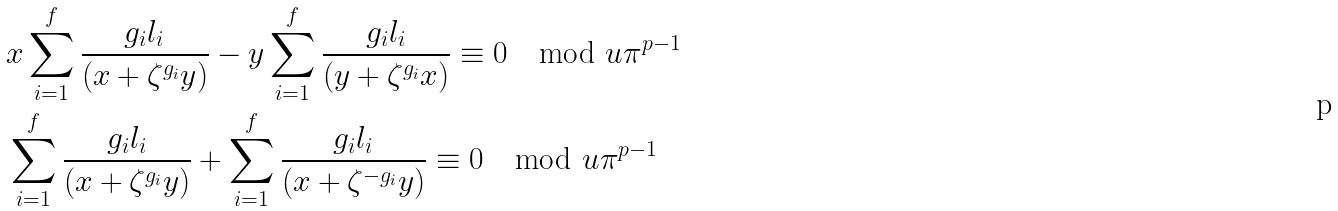<formula> <loc_0><loc_0><loc_500><loc_500>& x \sum _ { i = 1 } ^ { f } \frac { g _ { i } l _ { i } } { ( x + \zeta ^ { g _ { i } } y ) } - y \sum _ { i = 1 } ^ { f } \frac { g _ { i } l _ { i } } { ( y + \zeta ^ { g _ { i } } x ) } \equiv 0 \mod u \pi ^ { p - 1 } \\ & \sum _ { i = 1 } ^ { f } \frac { g _ { i } l _ { i } } { ( x + \zeta ^ { g _ { i } } y ) } + \sum _ { i = 1 } ^ { f } \frac { g _ { i } l _ { i } } { ( x + \zeta ^ { - g _ { i } } y ) } \equiv 0 \mod u \pi ^ { p - 1 }</formula> 